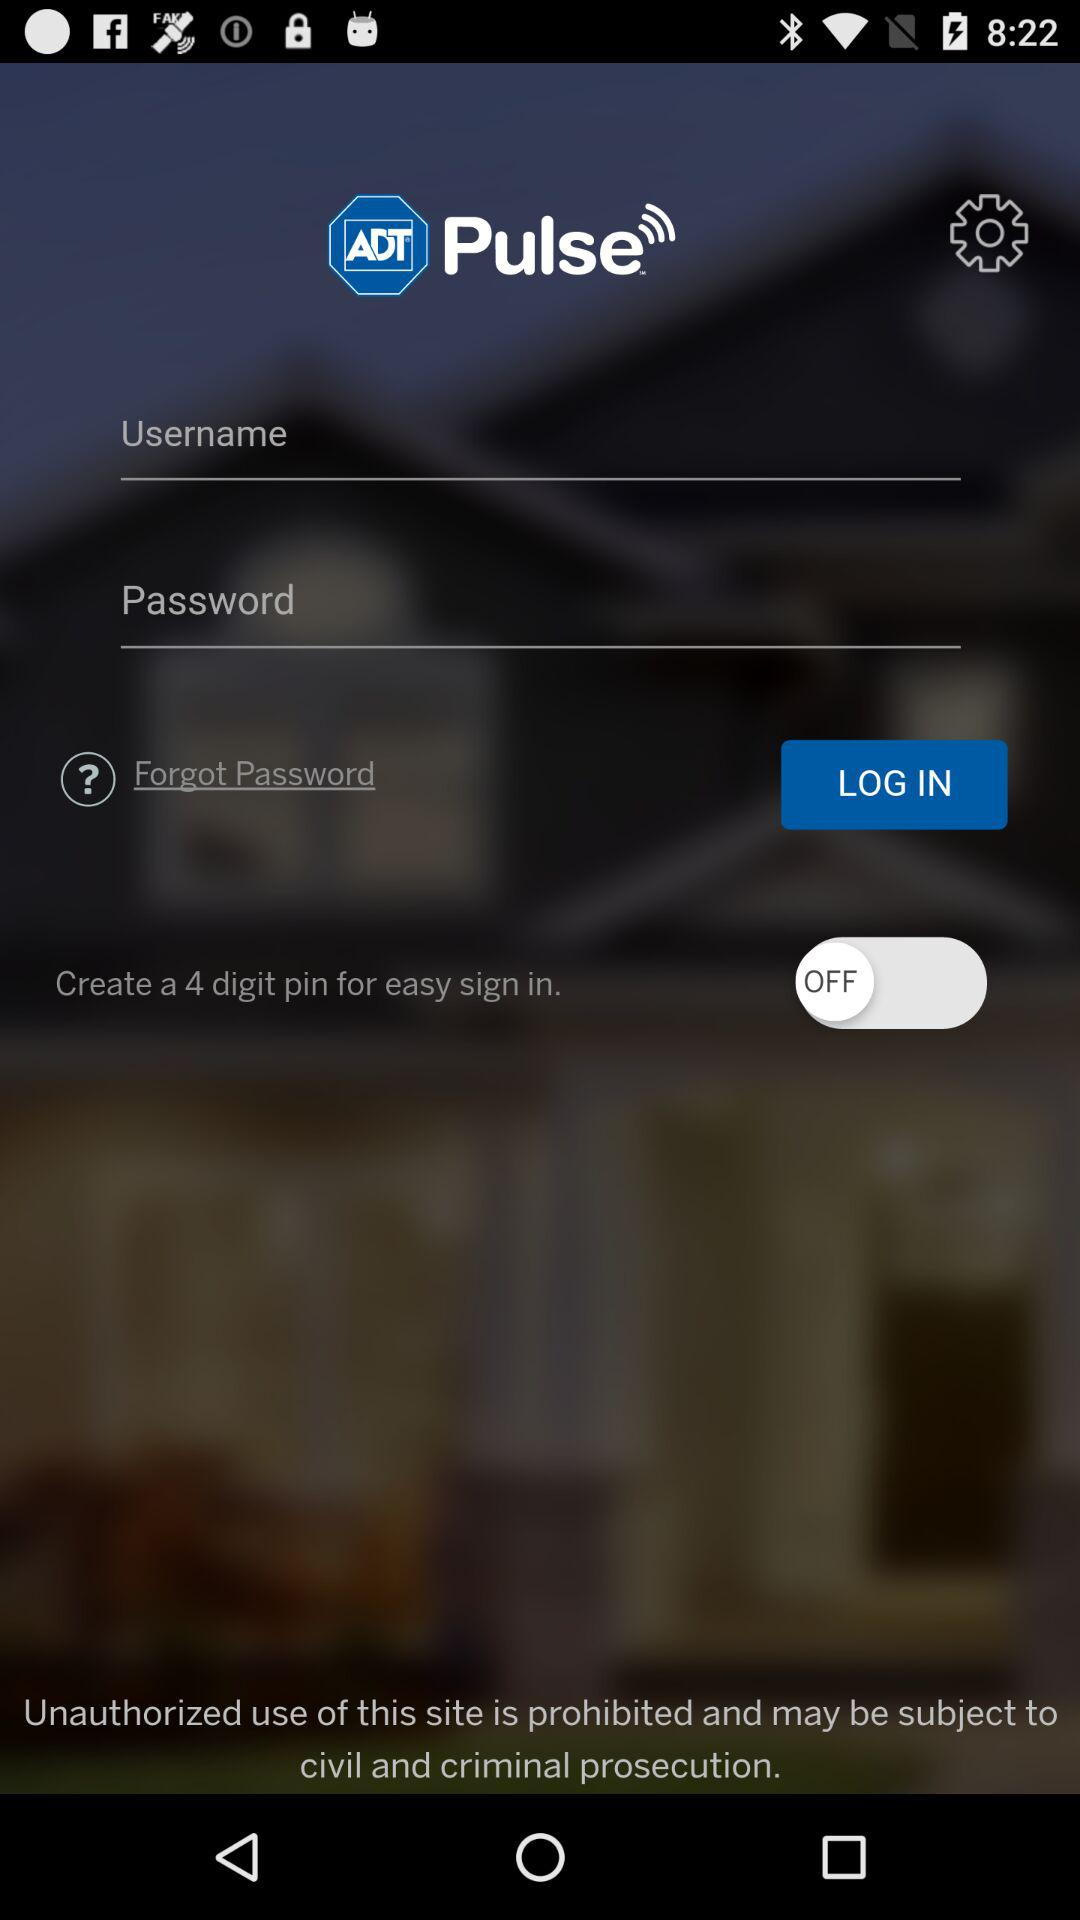What is the name of the application? The name of the application is "ADT Pulse". 